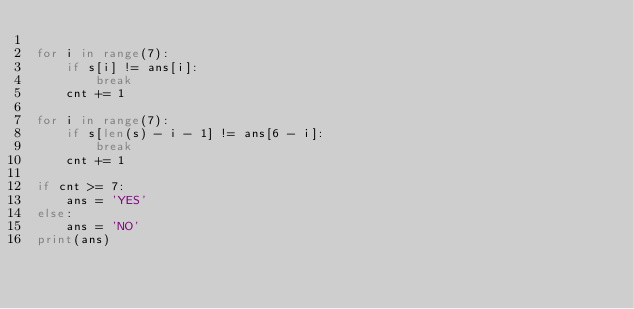<code> <loc_0><loc_0><loc_500><loc_500><_Python_>
for i in range(7):
    if s[i] != ans[i]:
        break
    cnt += 1

for i in range(7):
    if s[len(s) - i - 1] != ans[6 - i]:
        break
    cnt += 1

if cnt >= 7:
    ans = 'YES'
else:
    ans = 'NO'
print(ans)
</code> 